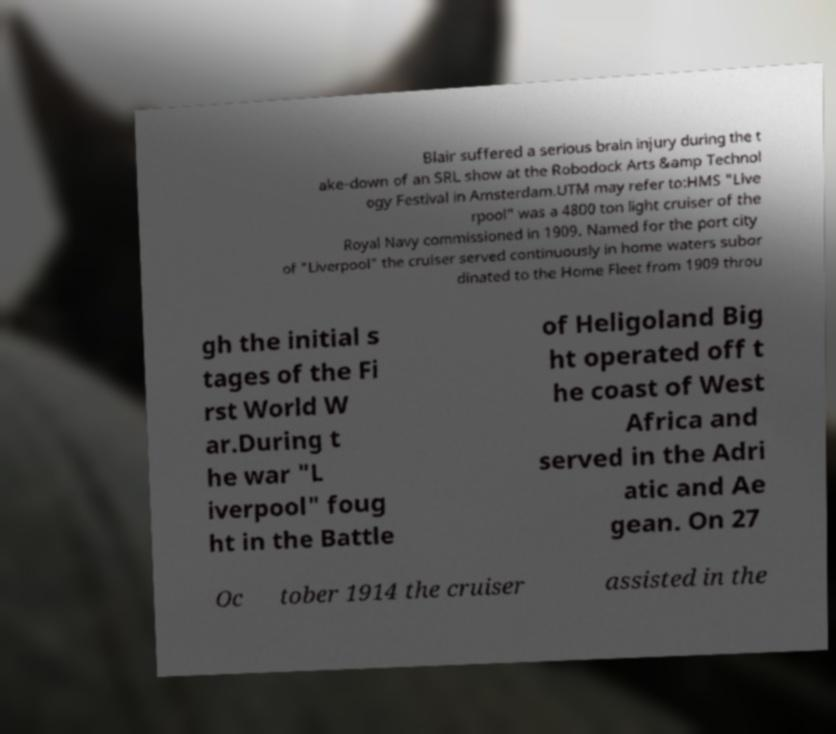Could you assist in decoding the text presented in this image and type it out clearly? Blair suffered a serious brain injury during the t ake-down of an SRL show at the Robodock Arts &amp Technol ogy Festival in Amsterdam.UTM may refer to:HMS "Live rpool" was a 4800 ton light cruiser of the Royal Navy commissioned in 1909. Named for the port city of "Liverpool" the cruiser served continuously in home waters subor dinated to the Home Fleet from 1909 throu gh the initial s tages of the Fi rst World W ar.During t he war "L iverpool" foug ht in the Battle of Heligoland Big ht operated off t he coast of West Africa and served in the Adri atic and Ae gean. On 27 Oc tober 1914 the cruiser assisted in the 